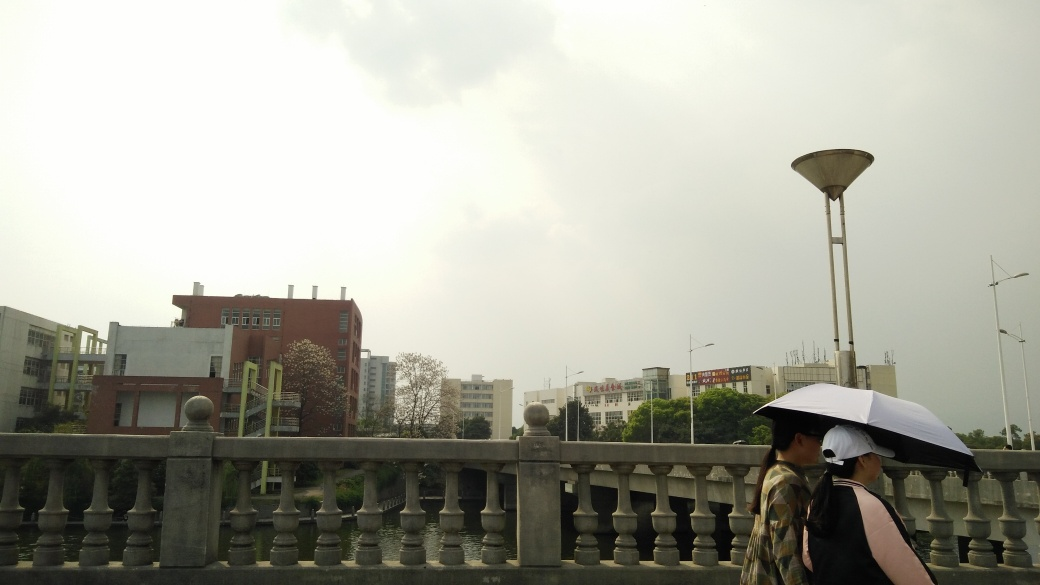What is the weather like in the scene depicted in the image? The weather appears overcast with a grey sky that suggests the possibility of rain, which is also indicated by the presence of an umbrella. Overall, the atmosphere seems calm but cloudy, typical of a day when rain could occur at any time. 